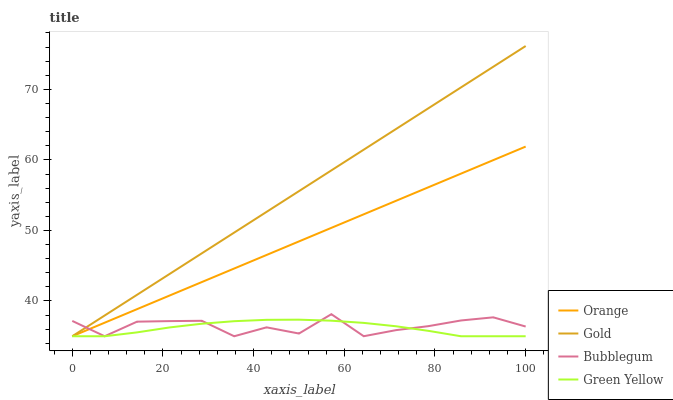Does Bubblegum have the minimum area under the curve?
Answer yes or no. No. Does Bubblegum have the maximum area under the curve?
Answer yes or no. No. Is Green Yellow the smoothest?
Answer yes or no. No. Is Green Yellow the roughest?
Answer yes or no. No. Does Bubblegum have the highest value?
Answer yes or no. No. 